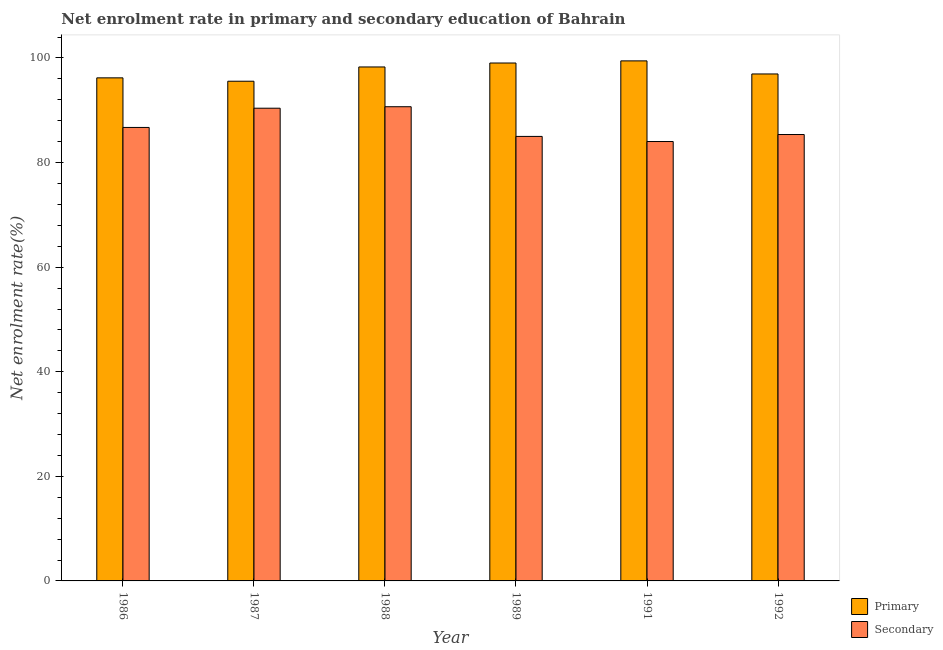How many different coloured bars are there?
Provide a short and direct response. 2. Are the number of bars on each tick of the X-axis equal?
Your answer should be compact. Yes. How many bars are there on the 3rd tick from the left?
Provide a succinct answer. 2. What is the enrollment rate in secondary education in 1989?
Provide a succinct answer. 85. Across all years, what is the maximum enrollment rate in secondary education?
Offer a very short reply. 90.68. Across all years, what is the minimum enrollment rate in primary education?
Offer a terse response. 95.56. In which year was the enrollment rate in primary education maximum?
Provide a short and direct response. 1991. What is the total enrollment rate in primary education in the graph?
Offer a terse response. 585.49. What is the difference between the enrollment rate in secondary education in 1987 and that in 1991?
Your response must be concise. 6.37. What is the difference between the enrollment rate in secondary education in 1988 and the enrollment rate in primary education in 1992?
Make the answer very short. 5.32. What is the average enrollment rate in secondary education per year?
Offer a very short reply. 87.03. In the year 1992, what is the difference between the enrollment rate in secondary education and enrollment rate in primary education?
Provide a succinct answer. 0. What is the ratio of the enrollment rate in secondary education in 1987 to that in 1991?
Your response must be concise. 1.08. Is the enrollment rate in secondary education in 1987 less than that in 1988?
Keep it short and to the point. Yes. Is the difference between the enrollment rate in secondary education in 1989 and 1992 greater than the difference between the enrollment rate in primary education in 1989 and 1992?
Your answer should be very brief. No. What is the difference between the highest and the second highest enrollment rate in primary education?
Make the answer very short. 0.41. What is the difference between the highest and the lowest enrollment rate in secondary education?
Your answer should be very brief. 6.65. In how many years, is the enrollment rate in primary education greater than the average enrollment rate in primary education taken over all years?
Keep it short and to the point. 3. Is the sum of the enrollment rate in primary education in 1986 and 1992 greater than the maximum enrollment rate in secondary education across all years?
Your answer should be compact. Yes. What does the 2nd bar from the left in 1988 represents?
Offer a terse response. Secondary. What does the 2nd bar from the right in 1986 represents?
Provide a short and direct response. Primary. Where does the legend appear in the graph?
Keep it short and to the point. Bottom right. What is the title of the graph?
Keep it short and to the point. Net enrolment rate in primary and secondary education of Bahrain. Does "% of GNI" appear as one of the legend labels in the graph?
Provide a short and direct response. No. What is the label or title of the Y-axis?
Your answer should be compact. Net enrolment rate(%). What is the Net enrolment rate(%) of Primary in 1986?
Your answer should be compact. 96.2. What is the Net enrolment rate(%) in Secondary in 1986?
Provide a short and direct response. 86.72. What is the Net enrolment rate(%) in Primary in 1987?
Provide a short and direct response. 95.56. What is the Net enrolment rate(%) of Secondary in 1987?
Offer a very short reply. 90.4. What is the Net enrolment rate(%) in Primary in 1988?
Ensure brevity in your answer.  98.29. What is the Net enrolment rate(%) of Secondary in 1988?
Keep it short and to the point. 90.68. What is the Net enrolment rate(%) of Primary in 1989?
Your answer should be very brief. 99.04. What is the Net enrolment rate(%) of Secondary in 1989?
Keep it short and to the point. 85. What is the Net enrolment rate(%) in Primary in 1991?
Provide a short and direct response. 99.45. What is the Net enrolment rate(%) in Secondary in 1991?
Provide a short and direct response. 84.03. What is the Net enrolment rate(%) in Primary in 1992?
Your answer should be very brief. 96.95. What is the Net enrolment rate(%) in Secondary in 1992?
Provide a short and direct response. 85.36. Across all years, what is the maximum Net enrolment rate(%) in Primary?
Offer a very short reply. 99.45. Across all years, what is the maximum Net enrolment rate(%) of Secondary?
Your answer should be compact. 90.68. Across all years, what is the minimum Net enrolment rate(%) in Primary?
Give a very brief answer. 95.56. Across all years, what is the minimum Net enrolment rate(%) in Secondary?
Offer a terse response. 84.03. What is the total Net enrolment rate(%) in Primary in the graph?
Ensure brevity in your answer.  585.49. What is the total Net enrolment rate(%) of Secondary in the graph?
Your response must be concise. 522.2. What is the difference between the Net enrolment rate(%) in Primary in 1986 and that in 1987?
Give a very brief answer. 0.65. What is the difference between the Net enrolment rate(%) in Secondary in 1986 and that in 1987?
Ensure brevity in your answer.  -3.68. What is the difference between the Net enrolment rate(%) in Primary in 1986 and that in 1988?
Ensure brevity in your answer.  -2.08. What is the difference between the Net enrolment rate(%) of Secondary in 1986 and that in 1988?
Your answer should be compact. -3.96. What is the difference between the Net enrolment rate(%) of Primary in 1986 and that in 1989?
Keep it short and to the point. -2.84. What is the difference between the Net enrolment rate(%) of Secondary in 1986 and that in 1989?
Your response must be concise. 1.72. What is the difference between the Net enrolment rate(%) of Primary in 1986 and that in 1991?
Your answer should be compact. -3.25. What is the difference between the Net enrolment rate(%) in Secondary in 1986 and that in 1991?
Your response must be concise. 2.69. What is the difference between the Net enrolment rate(%) of Primary in 1986 and that in 1992?
Your answer should be very brief. -0.74. What is the difference between the Net enrolment rate(%) in Secondary in 1986 and that in 1992?
Provide a succinct answer. 1.36. What is the difference between the Net enrolment rate(%) in Primary in 1987 and that in 1988?
Make the answer very short. -2.73. What is the difference between the Net enrolment rate(%) in Secondary in 1987 and that in 1988?
Your answer should be compact. -0.28. What is the difference between the Net enrolment rate(%) in Primary in 1987 and that in 1989?
Your response must be concise. -3.48. What is the difference between the Net enrolment rate(%) of Secondary in 1987 and that in 1989?
Make the answer very short. 5.4. What is the difference between the Net enrolment rate(%) in Primary in 1987 and that in 1991?
Your response must be concise. -3.89. What is the difference between the Net enrolment rate(%) in Secondary in 1987 and that in 1991?
Provide a succinct answer. 6.37. What is the difference between the Net enrolment rate(%) of Primary in 1987 and that in 1992?
Make the answer very short. -1.39. What is the difference between the Net enrolment rate(%) of Secondary in 1987 and that in 1992?
Offer a very short reply. 5.03. What is the difference between the Net enrolment rate(%) of Primary in 1988 and that in 1989?
Offer a very short reply. -0.76. What is the difference between the Net enrolment rate(%) in Secondary in 1988 and that in 1989?
Give a very brief answer. 5.68. What is the difference between the Net enrolment rate(%) of Primary in 1988 and that in 1991?
Provide a succinct answer. -1.16. What is the difference between the Net enrolment rate(%) of Secondary in 1988 and that in 1991?
Provide a succinct answer. 6.66. What is the difference between the Net enrolment rate(%) in Primary in 1988 and that in 1992?
Your answer should be compact. 1.34. What is the difference between the Net enrolment rate(%) of Secondary in 1988 and that in 1992?
Your response must be concise. 5.32. What is the difference between the Net enrolment rate(%) of Primary in 1989 and that in 1991?
Keep it short and to the point. -0.41. What is the difference between the Net enrolment rate(%) of Secondary in 1989 and that in 1991?
Offer a terse response. 0.98. What is the difference between the Net enrolment rate(%) of Primary in 1989 and that in 1992?
Offer a very short reply. 2.09. What is the difference between the Net enrolment rate(%) in Secondary in 1989 and that in 1992?
Give a very brief answer. -0.36. What is the difference between the Net enrolment rate(%) in Primary in 1991 and that in 1992?
Provide a succinct answer. 2.5. What is the difference between the Net enrolment rate(%) in Secondary in 1991 and that in 1992?
Keep it short and to the point. -1.34. What is the difference between the Net enrolment rate(%) in Primary in 1986 and the Net enrolment rate(%) in Secondary in 1987?
Make the answer very short. 5.81. What is the difference between the Net enrolment rate(%) of Primary in 1986 and the Net enrolment rate(%) of Secondary in 1988?
Provide a succinct answer. 5.52. What is the difference between the Net enrolment rate(%) in Primary in 1986 and the Net enrolment rate(%) in Secondary in 1989?
Make the answer very short. 11.2. What is the difference between the Net enrolment rate(%) in Primary in 1986 and the Net enrolment rate(%) in Secondary in 1991?
Your answer should be compact. 12.18. What is the difference between the Net enrolment rate(%) in Primary in 1986 and the Net enrolment rate(%) in Secondary in 1992?
Your answer should be very brief. 10.84. What is the difference between the Net enrolment rate(%) in Primary in 1987 and the Net enrolment rate(%) in Secondary in 1988?
Provide a short and direct response. 4.88. What is the difference between the Net enrolment rate(%) in Primary in 1987 and the Net enrolment rate(%) in Secondary in 1989?
Ensure brevity in your answer.  10.55. What is the difference between the Net enrolment rate(%) in Primary in 1987 and the Net enrolment rate(%) in Secondary in 1991?
Give a very brief answer. 11.53. What is the difference between the Net enrolment rate(%) of Primary in 1987 and the Net enrolment rate(%) of Secondary in 1992?
Your answer should be compact. 10.19. What is the difference between the Net enrolment rate(%) in Primary in 1988 and the Net enrolment rate(%) in Secondary in 1989?
Your answer should be compact. 13.28. What is the difference between the Net enrolment rate(%) in Primary in 1988 and the Net enrolment rate(%) in Secondary in 1991?
Keep it short and to the point. 14.26. What is the difference between the Net enrolment rate(%) in Primary in 1988 and the Net enrolment rate(%) in Secondary in 1992?
Offer a very short reply. 12.92. What is the difference between the Net enrolment rate(%) of Primary in 1989 and the Net enrolment rate(%) of Secondary in 1991?
Ensure brevity in your answer.  15.01. What is the difference between the Net enrolment rate(%) of Primary in 1989 and the Net enrolment rate(%) of Secondary in 1992?
Provide a short and direct response. 13.68. What is the difference between the Net enrolment rate(%) in Primary in 1991 and the Net enrolment rate(%) in Secondary in 1992?
Keep it short and to the point. 14.09. What is the average Net enrolment rate(%) of Primary per year?
Provide a succinct answer. 97.58. What is the average Net enrolment rate(%) of Secondary per year?
Provide a succinct answer. 87.03. In the year 1986, what is the difference between the Net enrolment rate(%) in Primary and Net enrolment rate(%) in Secondary?
Provide a succinct answer. 9.48. In the year 1987, what is the difference between the Net enrolment rate(%) of Primary and Net enrolment rate(%) of Secondary?
Provide a succinct answer. 5.16. In the year 1988, what is the difference between the Net enrolment rate(%) in Primary and Net enrolment rate(%) in Secondary?
Ensure brevity in your answer.  7.6. In the year 1989, what is the difference between the Net enrolment rate(%) in Primary and Net enrolment rate(%) in Secondary?
Ensure brevity in your answer.  14.04. In the year 1991, what is the difference between the Net enrolment rate(%) in Primary and Net enrolment rate(%) in Secondary?
Provide a succinct answer. 15.42. In the year 1992, what is the difference between the Net enrolment rate(%) of Primary and Net enrolment rate(%) of Secondary?
Give a very brief answer. 11.58. What is the ratio of the Net enrolment rate(%) in Primary in 1986 to that in 1987?
Make the answer very short. 1.01. What is the ratio of the Net enrolment rate(%) in Secondary in 1986 to that in 1987?
Offer a terse response. 0.96. What is the ratio of the Net enrolment rate(%) of Primary in 1986 to that in 1988?
Your response must be concise. 0.98. What is the ratio of the Net enrolment rate(%) of Secondary in 1986 to that in 1988?
Provide a succinct answer. 0.96. What is the ratio of the Net enrolment rate(%) in Primary in 1986 to that in 1989?
Offer a terse response. 0.97. What is the ratio of the Net enrolment rate(%) of Secondary in 1986 to that in 1989?
Give a very brief answer. 1.02. What is the ratio of the Net enrolment rate(%) in Primary in 1986 to that in 1991?
Ensure brevity in your answer.  0.97. What is the ratio of the Net enrolment rate(%) of Secondary in 1986 to that in 1991?
Keep it short and to the point. 1.03. What is the ratio of the Net enrolment rate(%) of Secondary in 1986 to that in 1992?
Offer a terse response. 1.02. What is the ratio of the Net enrolment rate(%) of Primary in 1987 to that in 1988?
Give a very brief answer. 0.97. What is the ratio of the Net enrolment rate(%) in Secondary in 1987 to that in 1988?
Your answer should be compact. 1. What is the ratio of the Net enrolment rate(%) in Primary in 1987 to that in 1989?
Offer a terse response. 0.96. What is the ratio of the Net enrolment rate(%) of Secondary in 1987 to that in 1989?
Offer a terse response. 1.06. What is the ratio of the Net enrolment rate(%) of Primary in 1987 to that in 1991?
Your response must be concise. 0.96. What is the ratio of the Net enrolment rate(%) of Secondary in 1987 to that in 1991?
Provide a succinct answer. 1.08. What is the ratio of the Net enrolment rate(%) of Primary in 1987 to that in 1992?
Provide a short and direct response. 0.99. What is the ratio of the Net enrolment rate(%) of Secondary in 1987 to that in 1992?
Your answer should be very brief. 1.06. What is the ratio of the Net enrolment rate(%) in Secondary in 1988 to that in 1989?
Your answer should be compact. 1.07. What is the ratio of the Net enrolment rate(%) in Primary in 1988 to that in 1991?
Give a very brief answer. 0.99. What is the ratio of the Net enrolment rate(%) of Secondary in 1988 to that in 1991?
Your response must be concise. 1.08. What is the ratio of the Net enrolment rate(%) in Primary in 1988 to that in 1992?
Ensure brevity in your answer.  1.01. What is the ratio of the Net enrolment rate(%) of Secondary in 1988 to that in 1992?
Provide a short and direct response. 1.06. What is the ratio of the Net enrolment rate(%) in Primary in 1989 to that in 1991?
Give a very brief answer. 1. What is the ratio of the Net enrolment rate(%) in Secondary in 1989 to that in 1991?
Ensure brevity in your answer.  1.01. What is the ratio of the Net enrolment rate(%) in Primary in 1989 to that in 1992?
Offer a very short reply. 1.02. What is the ratio of the Net enrolment rate(%) of Primary in 1991 to that in 1992?
Provide a succinct answer. 1.03. What is the ratio of the Net enrolment rate(%) of Secondary in 1991 to that in 1992?
Offer a terse response. 0.98. What is the difference between the highest and the second highest Net enrolment rate(%) of Primary?
Your answer should be compact. 0.41. What is the difference between the highest and the second highest Net enrolment rate(%) of Secondary?
Offer a terse response. 0.28. What is the difference between the highest and the lowest Net enrolment rate(%) of Primary?
Give a very brief answer. 3.89. What is the difference between the highest and the lowest Net enrolment rate(%) of Secondary?
Provide a succinct answer. 6.66. 